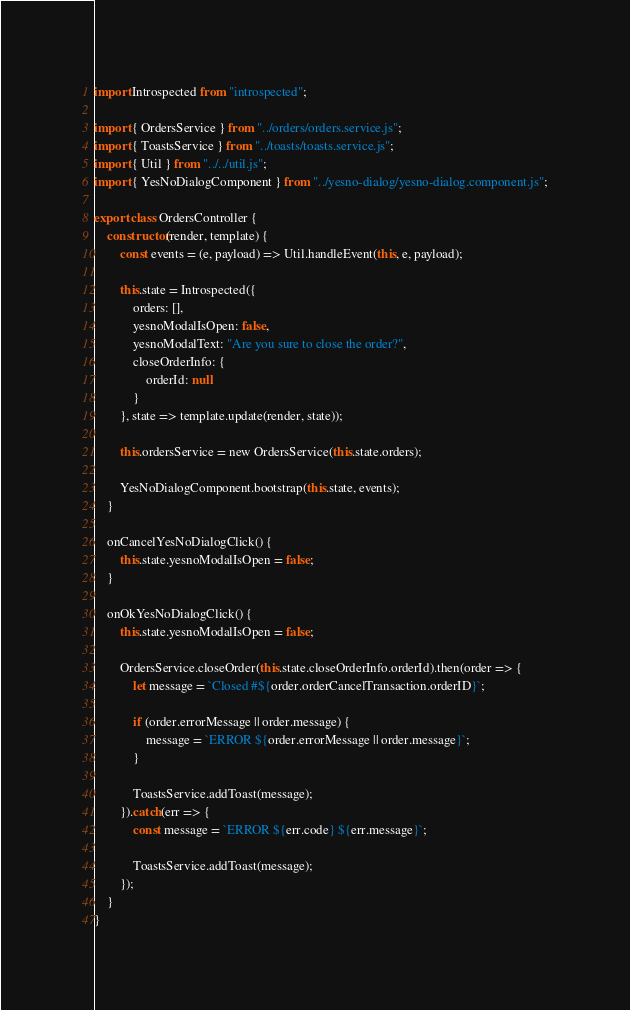Convert code to text. <code><loc_0><loc_0><loc_500><loc_500><_JavaScript_>import Introspected from "introspected";

import { OrdersService } from "../orders/orders.service.js";
import { ToastsService } from "../toasts/toasts.service.js";
import { Util } from "../../util.js";
import { YesNoDialogComponent } from "../yesno-dialog/yesno-dialog.component.js";

export class OrdersController {
    constructor(render, template) {
        const events = (e, payload) => Util.handleEvent(this, e, payload);

        this.state = Introspected({
            orders: [],
            yesnoModalIsOpen: false,
            yesnoModalText: "Are you sure to close the order?",
            closeOrderInfo: {
                orderId: null
            }
        }, state => template.update(render, state));

        this.ordersService = new OrdersService(this.state.orders);

        YesNoDialogComponent.bootstrap(this.state, events);
    }

    onCancelYesNoDialogClick() {
        this.state.yesnoModalIsOpen = false;
    }

    onOkYesNoDialogClick() {
        this.state.yesnoModalIsOpen = false;

        OrdersService.closeOrder(this.state.closeOrderInfo.orderId).then(order => {
            let message = `Closed #${order.orderCancelTransaction.orderID}`;

            if (order.errorMessage || order.message) {
                message = `ERROR ${order.errorMessage || order.message}`;
            }

            ToastsService.addToast(message);
        }).catch(err => {
            const message = `ERROR ${err.code} ${err.message}`;

            ToastsService.addToast(message);
        });
    }
}
</code> 